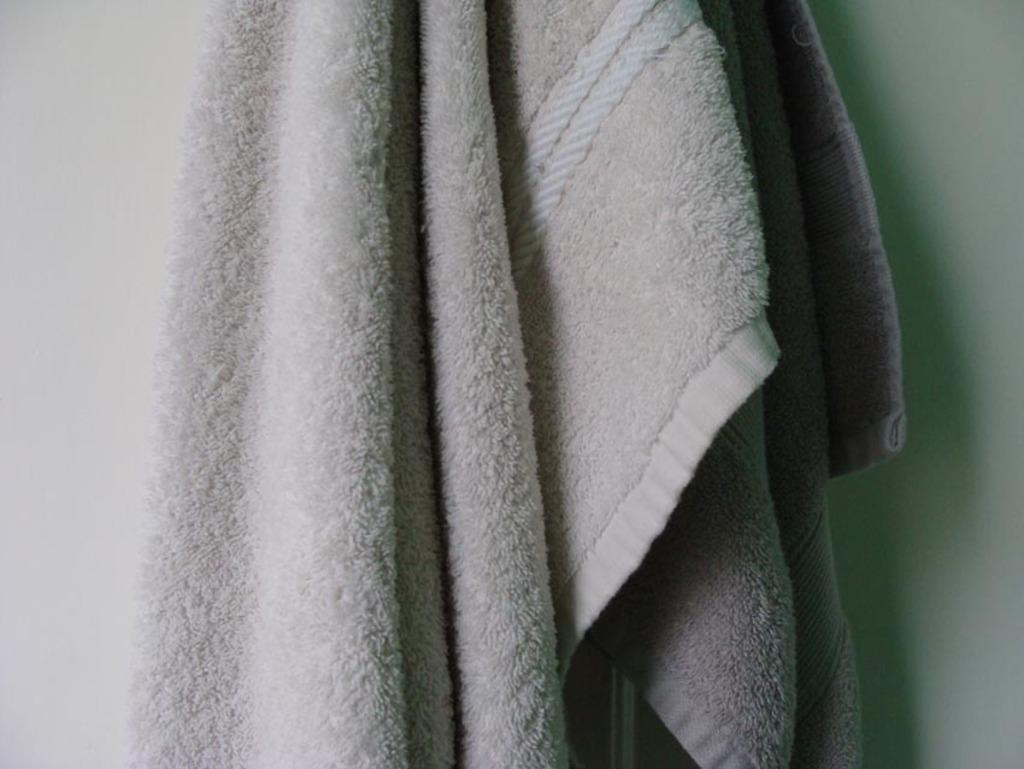What object can be seen in the image? There is a towel in the image. What color is the towel? The towel is white. What can be observed about the background of the image? The background of the image is white. Can you see an owl helping someone in the image? There is no owl or any indication of someone being helped in the image; it only features a white towel. 